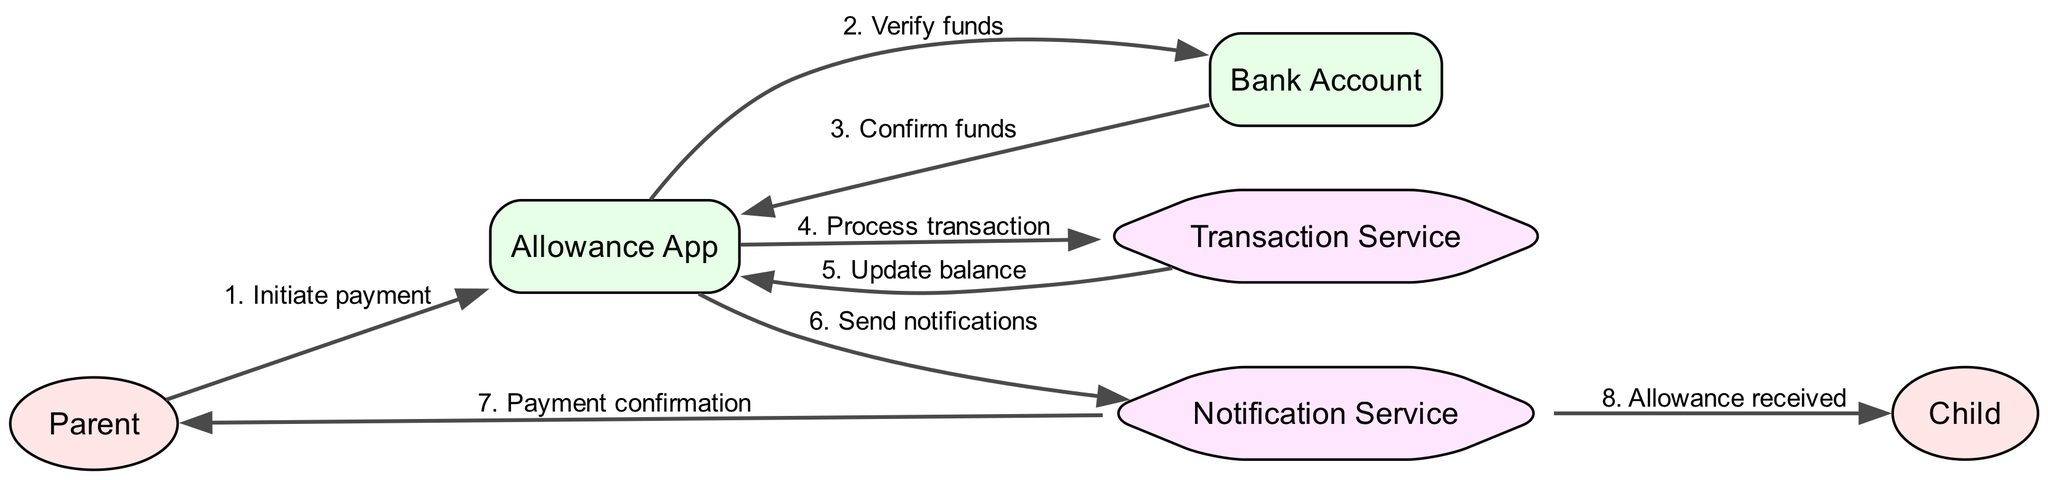What is the first action in the sequence? The first action in the sequence is where the Parent initiates the payment, as shown by the first arrow pointing from the Parent to the Allowance App.
Answer: Initiate payment How many actors are present in the diagram? The diagram contains two actors: the Parent and the Child, which are clearly labeled in the diagram.
Answer: 2 Which service sends notifications to the Parent and Child? The Notification Service is responsible for sending confirmations about the payment, as indicated in the actions where it sends notifications to both the Parent and the Child.
Answer: Notification Service What is the last action shown in the sequence? The last action in the sequence is the notification sent by the Notification Service to the Child indicating that the allowance was received.
Answer: Allowance received What verifies the funds before the transaction is processed? The verification of funds is done by the Bank Account, as shown in the flow where the Allowance App queries the Bank Account to confirm the available funds before proceeding with the transaction.
Answer: Bank Account Which system processes the transaction? The system dedicated to processing the transaction is the Transaction Service, as indicated by its role in the sequence of actions.
Answer: Transaction Service How many total actions occur in the transaction flow? By counting the listed actions from initiation to notification, there are a total of eight actions in the transaction flow.
Answer: 8 What updates the balance after processing the transaction? The balance is updated by the Transaction Service, after it processes the transaction, which is indicated in the flow of actions.
Answer: Transaction Service 